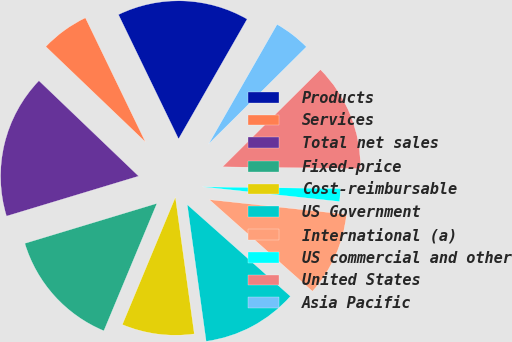Convert chart. <chart><loc_0><loc_0><loc_500><loc_500><pie_chart><fcel>Products<fcel>Services<fcel>Total net sales<fcel>Fixed-price<fcel>Cost-reimbursable<fcel>US Government<fcel>International (a)<fcel>US commercial and other<fcel>United States<fcel>Asia Pacific<nl><fcel>15.44%<fcel>5.68%<fcel>16.83%<fcel>14.04%<fcel>8.47%<fcel>11.25%<fcel>9.86%<fcel>1.5%<fcel>12.65%<fcel>4.28%<nl></chart> 